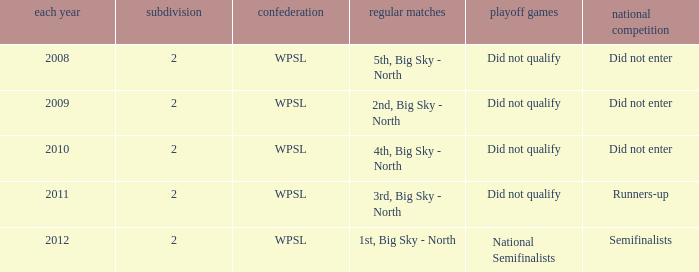What league was involved in 2010? WPSL. 